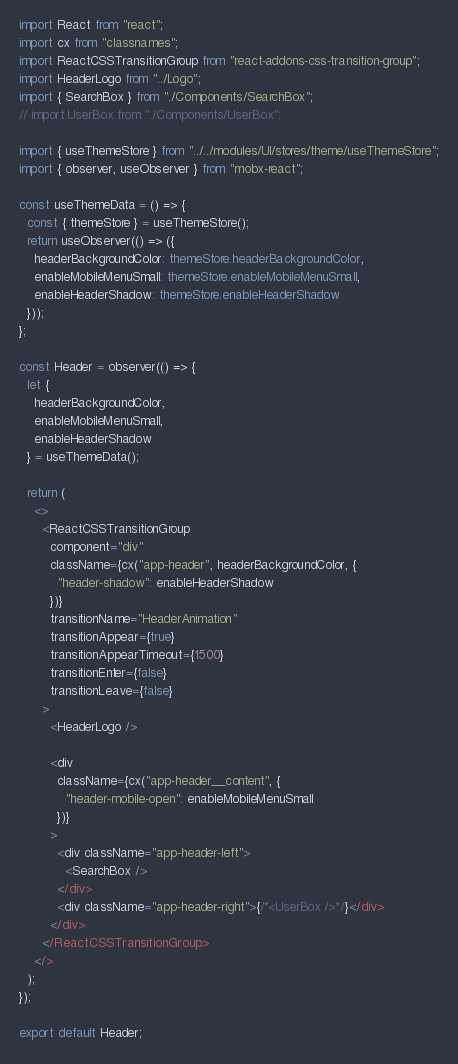<code> <loc_0><loc_0><loc_500><loc_500><_TypeScript_>import React from "react";
import cx from "classnames";
import ReactCSSTransitionGroup from "react-addons-css-transition-group";
import HeaderLogo from "../Logo";
import { SearchBox } from "./Components/SearchBox";
// import UserBox from "./Components/UserBox";

import { useThemeStore } from "../../modules/UI/stores/theme/useThemeStore";
import { observer, useObserver } from "mobx-react";

const useThemeData = () => {
  const { themeStore } = useThemeStore();
  return useObserver(() => ({
    headerBackgroundColor: themeStore.headerBackgroundColor,
    enableMobileMenuSmall: themeStore.enableMobileMenuSmall,
    enableHeaderShadow: themeStore.enableHeaderShadow
  }));
};

const Header = observer(() => {
  let {
    headerBackgroundColor,
    enableMobileMenuSmall,
    enableHeaderShadow
  } = useThemeData();

  return (
    <>
      <ReactCSSTransitionGroup
        component="div"
        className={cx("app-header", headerBackgroundColor, {
          "header-shadow": enableHeaderShadow
        })}
        transitionName="HeaderAnimation"
        transitionAppear={true}
        transitionAppearTimeout={1500}
        transitionEnter={false}
        transitionLeave={false}
      >
        <HeaderLogo />

        <div
          className={cx("app-header__content", {
            "header-mobile-open": enableMobileMenuSmall
          })}
        >
          <div className="app-header-left">
            <SearchBox />
          </div>
          <div className="app-header-right">{/*<UserBox />*/}</div>
        </div>
      </ReactCSSTransitionGroup>
    </>
  );
});

export default Header;
</code> 